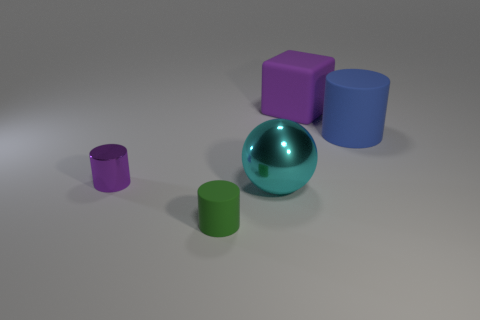Is there any other thing that is the same shape as the purple matte object?
Offer a very short reply. No. Is the color of the tiny cylinder that is behind the green thing the same as the thing that is behind the large blue object?
Provide a short and direct response. Yes. How many small rubber cylinders are on the right side of the purple matte thing?
Your answer should be very brief. 0. How many rubber blocks have the same color as the metal cylinder?
Your answer should be compact. 1. Is the large thing to the right of the purple cube made of the same material as the purple cube?
Offer a terse response. Yes. What number of tiny green objects have the same material as the large blue cylinder?
Offer a terse response. 1. Are there more cyan things behind the big shiny object than rubber cubes?
Ensure brevity in your answer.  No. The cylinder that is the same color as the rubber cube is what size?
Offer a terse response. Small. Is there another big cyan shiny thing that has the same shape as the big cyan object?
Give a very brief answer. No. How many objects are small rubber blocks or small things?
Keep it short and to the point. 2. 